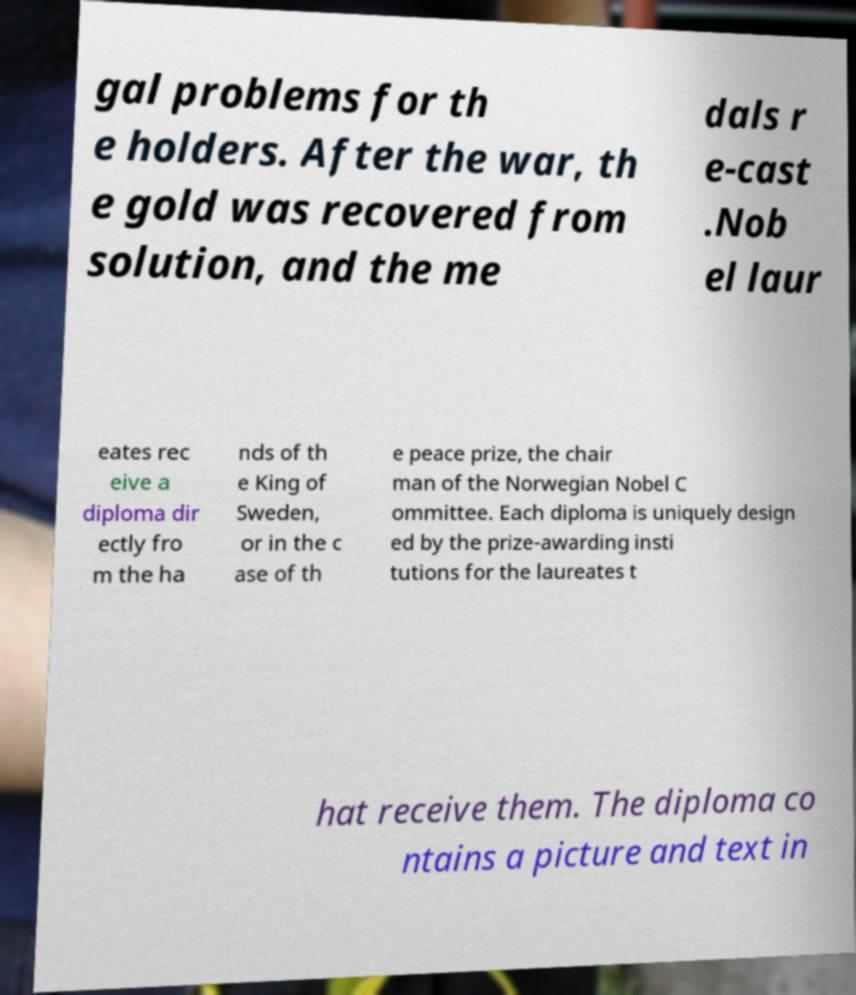Can you read and provide the text displayed in the image?This photo seems to have some interesting text. Can you extract and type it out for me? gal problems for th e holders. After the war, th e gold was recovered from solution, and the me dals r e-cast .Nob el laur eates rec eive a diploma dir ectly fro m the ha nds of th e King of Sweden, or in the c ase of th e peace prize, the chair man of the Norwegian Nobel C ommittee. Each diploma is uniquely design ed by the prize-awarding insti tutions for the laureates t hat receive them. The diploma co ntains a picture and text in 